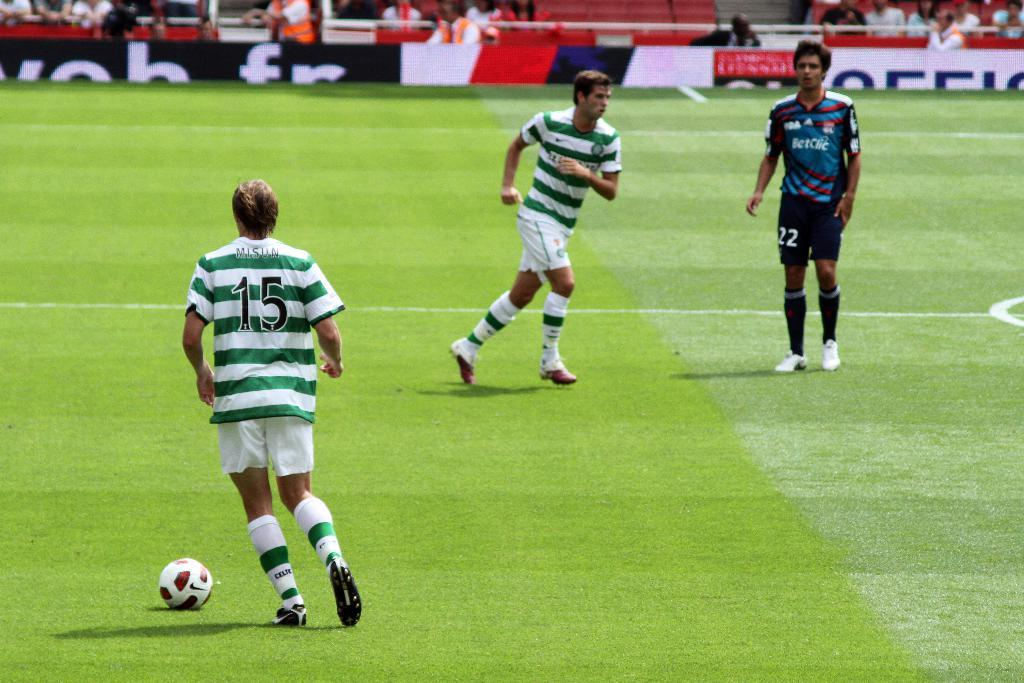What are the people in the image doing? The persons standing on the ground are likely participating in an activity or event. What object can be seen in the image besides the people? A ball is present in the image. What can be seen in the background of the image? There are advertisement boards and spectators visible in the background. What type of waste is being discussed by the persons in the image? There is no discussion or waste present in the image; it features people standing on the ground, a ball, advertisement boards, and spectators. How much money is being exchanged between the persons in the image? There is no indication of any money exchange in the image; it simply shows people standing on the ground, a ball, advertisement boards, and spectators. 